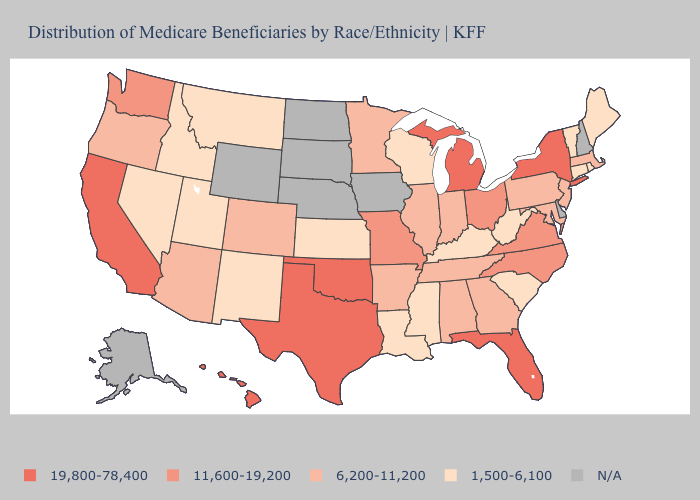Which states have the lowest value in the West?
Be succinct. Idaho, Montana, Nevada, New Mexico, Utah. Name the states that have a value in the range 6,200-11,200?
Keep it brief. Alabama, Arizona, Arkansas, Colorado, Georgia, Illinois, Indiana, Maryland, Massachusetts, Minnesota, New Jersey, Oregon, Pennsylvania, Tennessee. Name the states that have a value in the range 6,200-11,200?
Be succinct. Alabama, Arizona, Arkansas, Colorado, Georgia, Illinois, Indiana, Maryland, Massachusetts, Minnesota, New Jersey, Oregon, Pennsylvania, Tennessee. Name the states that have a value in the range 19,800-78,400?
Be succinct. California, Florida, Hawaii, Michigan, New York, Oklahoma, Texas. Name the states that have a value in the range 19,800-78,400?
Give a very brief answer. California, Florida, Hawaii, Michigan, New York, Oklahoma, Texas. What is the value of Indiana?
Answer briefly. 6,200-11,200. Among the states that border Louisiana , does Texas have the highest value?
Keep it brief. Yes. Name the states that have a value in the range 6,200-11,200?
Give a very brief answer. Alabama, Arizona, Arkansas, Colorado, Georgia, Illinois, Indiana, Maryland, Massachusetts, Minnesota, New Jersey, Oregon, Pennsylvania, Tennessee. What is the lowest value in states that border California?
Quick response, please. 1,500-6,100. What is the value of Iowa?
Short answer required. N/A. Name the states that have a value in the range 1,500-6,100?
Short answer required. Connecticut, Idaho, Kansas, Kentucky, Louisiana, Maine, Mississippi, Montana, Nevada, New Mexico, Rhode Island, South Carolina, Utah, Vermont, West Virginia, Wisconsin. Among the states that border New York , which have the highest value?
Short answer required. Massachusetts, New Jersey, Pennsylvania. 